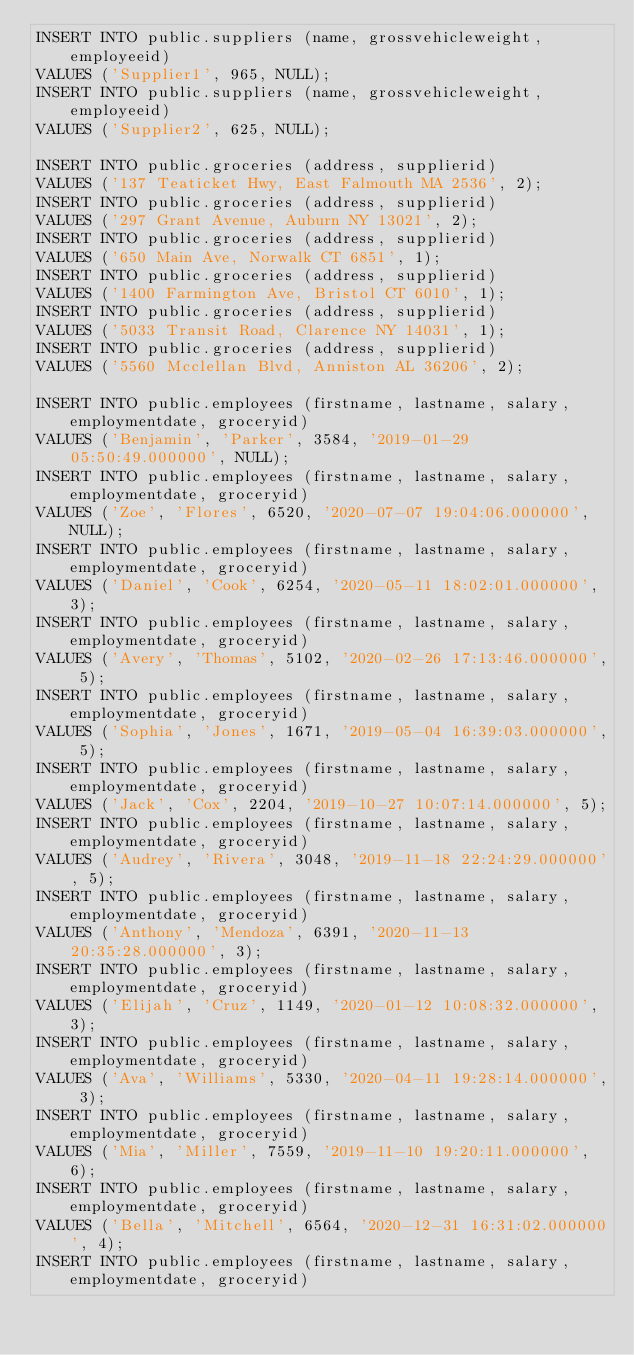<code> <loc_0><loc_0><loc_500><loc_500><_SQL_>INSERT INTO public.suppliers (name, grossvehicleweight, employeeid)
VALUES ('Supplier1', 965, NULL);
INSERT INTO public.suppliers (name, grossvehicleweight, employeeid)
VALUES ('Supplier2', 625, NULL);

INSERT INTO public.groceries (address, supplierid)
VALUES ('137 Teaticket Hwy, East Falmouth MA 2536', 2);
INSERT INTO public.groceries (address, supplierid)
VALUES ('297 Grant Avenue, Auburn NY 13021', 2);
INSERT INTO public.groceries (address, supplierid)
VALUES ('650 Main Ave, Norwalk CT 6851', 1);
INSERT INTO public.groceries (address, supplierid)
VALUES ('1400 Farmington Ave, Bristol CT 6010', 1);
INSERT INTO public.groceries (address, supplierid)
VALUES ('5033 Transit Road, Clarence NY 14031', 1);
INSERT INTO public.groceries (address, supplierid)
VALUES ('5560 Mcclellan Blvd, Anniston AL 36206', 2);

INSERT INTO public.employees (firstname, lastname, salary, employmentdate, groceryid)
VALUES ('Benjamin', 'Parker', 3584, '2019-01-29 05:50:49.000000', NULL);
INSERT INTO public.employees (firstname, lastname, salary, employmentdate, groceryid)
VALUES ('Zoe', 'Flores', 6520, '2020-07-07 19:04:06.000000', NULL);
INSERT INTO public.employees (firstname, lastname, salary, employmentdate, groceryid)
VALUES ('Daniel', 'Cook', 6254, '2020-05-11 18:02:01.000000', 3);
INSERT INTO public.employees (firstname, lastname, salary, employmentdate, groceryid)
VALUES ('Avery', 'Thomas', 5102, '2020-02-26 17:13:46.000000', 5);
INSERT INTO public.employees (firstname, lastname, salary, employmentdate, groceryid)
VALUES ('Sophia', 'Jones', 1671, '2019-05-04 16:39:03.000000', 5);
INSERT INTO public.employees (firstname, lastname, salary, employmentdate, groceryid)
VALUES ('Jack', 'Cox', 2204, '2019-10-27 10:07:14.000000', 5);
INSERT INTO public.employees (firstname, lastname, salary, employmentdate, groceryid)
VALUES ('Audrey', 'Rivera', 3048, '2019-11-18 22:24:29.000000', 5);
INSERT INTO public.employees (firstname, lastname, salary, employmentdate, groceryid)
VALUES ('Anthony', 'Mendoza', 6391, '2020-11-13 20:35:28.000000', 3);
INSERT INTO public.employees (firstname, lastname, salary, employmentdate, groceryid)
VALUES ('Elijah', 'Cruz', 1149, '2020-01-12 10:08:32.000000', 3);
INSERT INTO public.employees (firstname, lastname, salary, employmentdate, groceryid)
VALUES ('Ava', 'Williams', 5330, '2020-04-11 19:28:14.000000', 3);
INSERT INTO public.employees (firstname, lastname, salary, employmentdate, groceryid)
VALUES ('Mia', 'Miller', 7559, '2019-11-10 19:20:11.000000', 6);
INSERT INTO public.employees (firstname, lastname, salary, employmentdate, groceryid)
VALUES ('Bella', 'Mitchell', 6564, '2020-12-31 16:31:02.000000', 4);
INSERT INTO public.employees (firstname, lastname, salary, employmentdate, groceryid)</code> 